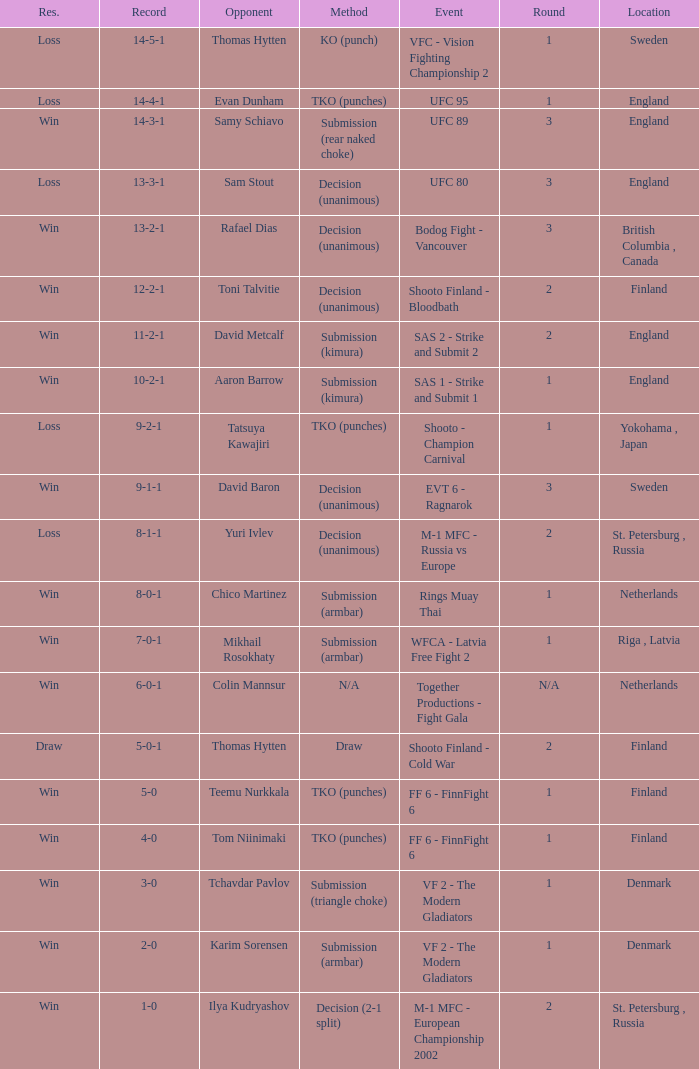What is the round in Finland with a draw for method? 2.0. 